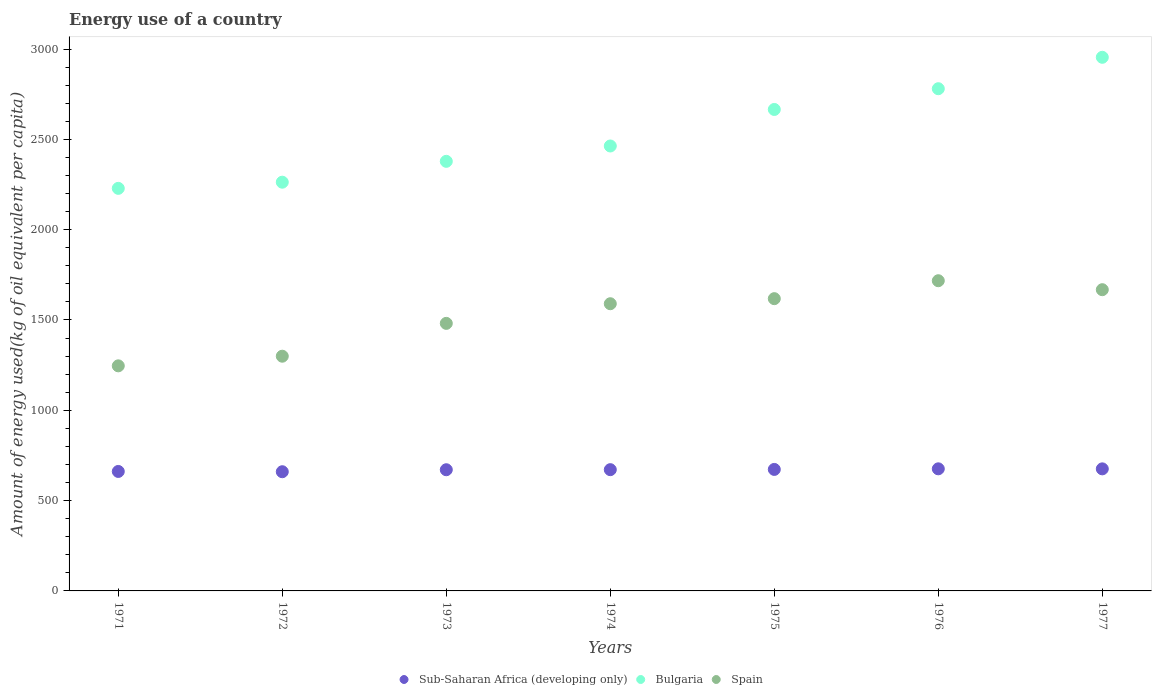Is the number of dotlines equal to the number of legend labels?
Your answer should be compact. Yes. What is the amount of energy used in in Sub-Saharan Africa (developing only) in 1973?
Your response must be concise. 670.89. Across all years, what is the maximum amount of energy used in in Sub-Saharan Africa (developing only)?
Provide a succinct answer. 675.94. Across all years, what is the minimum amount of energy used in in Bulgaria?
Offer a terse response. 2228.69. In which year was the amount of energy used in in Spain minimum?
Offer a very short reply. 1971. What is the total amount of energy used in in Bulgaria in the graph?
Offer a very short reply. 1.77e+04. What is the difference between the amount of energy used in in Bulgaria in 1971 and that in 1972?
Make the answer very short. -34.1. What is the difference between the amount of energy used in in Bulgaria in 1972 and the amount of energy used in in Spain in 1976?
Keep it short and to the point. 545.47. What is the average amount of energy used in in Sub-Saharan Africa (developing only) per year?
Offer a very short reply. 669.69. In the year 1975, what is the difference between the amount of energy used in in Spain and amount of energy used in in Sub-Saharan Africa (developing only)?
Offer a terse response. 945.38. What is the ratio of the amount of energy used in in Bulgaria in 1972 to that in 1974?
Give a very brief answer. 0.92. Is the amount of energy used in in Bulgaria in 1972 less than that in 1975?
Provide a short and direct response. Yes. Is the difference between the amount of energy used in in Spain in 1973 and 1977 greater than the difference between the amount of energy used in in Sub-Saharan Africa (developing only) in 1973 and 1977?
Make the answer very short. No. What is the difference between the highest and the second highest amount of energy used in in Sub-Saharan Africa (developing only)?
Your response must be concise. 0.17. What is the difference between the highest and the lowest amount of energy used in in Spain?
Ensure brevity in your answer.  471.22. Is the sum of the amount of energy used in in Bulgaria in 1973 and 1975 greater than the maximum amount of energy used in in Spain across all years?
Give a very brief answer. Yes. Is it the case that in every year, the sum of the amount of energy used in in Spain and amount of energy used in in Bulgaria  is greater than the amount of energy used in in Sub-Saharan Africa (developing only)?
Ensure brevity in your answer.  Yes. Does the amount of energy used in in Bulgaria monotonically increase over the years?
Your answer should be very brief. Yes. Is the amount of energy used in in Bulgaria strictly greater than the amount of energy used in in Spain over the years?
Your response must be concise. Yes. Is the amount of energy used in in Spain strictly less than the amount of energy used in in Bulgaria over the years?
Your response must be concise. Yes. How many dotlines are there?
Offer a very short reply. 3. Where does the legend appear in the graph?
Offer a very short reply. Bottom center. How many legend labels are there?
Give a very brief answer. 3. What is the title of the graph?
Your answer should be compact. Energy use of a country. Does "Gambia, The" appear as one of the legend labels in the graph?
Your answer should be very brief. No. What is the label or title of the Y-axis?
Ensure brevity in your answer.  Amount of energy used(kg of oil equivalent per capita). What is the Amount of energy used(kg of oil equivalent per capita) in Sub-Saharan Africa (developing only) in 1971?
Ensure brevity in your answer.  661.41. What is the Amount of energy used(kg of oil equivalent per capita) in Bulgaria in 1971?
Offer a very short reply. 2228.69. What is the Amount of energy used(kg of oil equivalent per capita) in Spain in 1971?
Provide a short and direct response. 1246.1. What is the Amount of energy used(kg of oil equivalent per capita) of Sub-Saharan Africa (developing only) in 1972?
Ensure brevity in your answer.  659.87. What is the Amount of energy used(kg of oil equivalent per capita) of Bulgaria in 1972?
Make the answer very short. 2262.79. What is the Amount of energy used(kg of oil equivalent per capita) in Spain in 1972?
Provide a short and direct response. 1299.43. What is the Amount of energy used(kg of oil equivalent per capita) of Sub-Saharan Africa (developing only) in 1973?
Your answer should be compact. 670.89. What is the Amount of energy used(kg of oil equivalent per capita) of Bulgaria in 1973?
Ensure brevity in your answer.  2378.25. What is the Amount of energy used(kg of oil equivalent per capita) of Spain in 1973?
Give a very brief answer. 1481.23. What is the Amount of energy used(kg of oil equivalent per capita) in Sub-Saharan Africa (developing only) in 1974?
Provide a succinct answer. 671.28. What is the Amount of energy used(kg of oil equivalent per capita) in Bulgaria in 1974?
Make the answer very short. 2463.24. What is the Amount of energy used(kg of oil equivalent per capita) in Spain in 1974?
Provide a short and direct response. 1589.97. What is the Amount of energy used(kg of oil equivalent per capita) in Sub-Saharan Africa (developing only) in 1975?
Ensure brevity in your answer.  672.65. What is the Amount of energy used(kg of oil equivalent per capita) of Bulgaria in 1975?
Ensure brevity in your answer.  2665.46. What is the Amount of energy used(kg of oil equivalent per capita) in Spain in 1975?
Provide a short and direct response. 1618.02. What is the Amount of energy used(kg of oil equivalent per capita) of Sub-Saharan Africa (developing only) in 1976?
Give a very brief answer. 675.94. What is the Amount of energy used(kg of oil equivalent per capita) of Bulgaria in 1976?
Offer a very short reply. 2780.33. What is the Amount of energy used(kg of oil equivalent per capita) of Spain in 1976?
Offer a very short reply. 1717.31. What is the Amount of energy used(kg of oil equivalent per capita) in Sub-Saharan Africa (developing only) in 1977?
Provide a succinct answer. 675.77. What is the Amount of energy used(kg of oil equivalent per capita) in Bulgaria in 1977?
Keep it short and to the point. 2954.27. What is the Amount of energy used(kg of oil equivalent per capita) of Spain in 1977?
Make the answer very short. 1667.65. Across all years, what is the maximum Amount of energy used(kg of oil equivalent per capita) of Sub-Saharan Africa (developing only)?
Offer a terse response. 675.94. Across all years, what is the maximum Amount of energy used(kg of oil equivalent per capita) in Bulgaria?
Your answer should be very brief. 2954.27. Across all years, what is the maximum Amount of energy used(kg of oil equivalent per capita) of Spain?
Offer a very short reply. 1717.31. Across all years, what is the minimum Amount of energy used(kg of oil equivalent per capita) in Sub-Saharan Africa (developing only)?
Your response must be concise. 659.87. Across all years, what is the minimum Amount of energy used(kg of oil equivalent per capita) in Bulgaria?
Keep it short and to the point. 2228.69. Across all years, what is the minimum Amount of energy used(kg of oil equivalent per capita) in Spain?
Give a very brief answer. 1246.1. What is the total Amount of energy used(kg of oil equivalent per capita) of Sub-Saharan Africa (developing only) in the graph?
Your answer should be very brief. 4687.81. What is the total Amount of energy used(kg of oil equivalent per capita) of Bulgaria in the graph?
Make the answer very short. 1.77e+04. What is the total Amount of energy used(kg of oil equivalent per capita) in Spain in the graph?
Offer a terse response. 1.06e+04. What is the difference between the Amount of energy used(kg of oil equivalent per capita) of Sub-Saharan Africa (developing only) in 1971 and that in 1972?
Make the answer very short. 1.54. What is the difference between the Amount of energy used(kg of oil equivalent per capita) of Bulgaria in 1971 and that in 1972?
Your answer should be compact. -34.1. What is the difference between the Amount of energy used(kg of oil equivalent per capita) of Spain in 1971 and that in 1972?
Your response must be concise. -53.33. What is the difference between the Amount of energy used(kg of oil equivalent per capita) of Sub-Saharan Africa (developing only) in 1971 and that in 1973?
Give a very brief answer. -9.49. What is the difference between the Amount of energy used(kg of oil equivalent per capita) in Bulgaria in 1971 and that in 1973?
Your answer should be compact. -149.57. What is the difference between the Amount of energy used(kg of oil equivalent per capita) in Spain in 1971 and that in 1973?
Offer a very short reply. -235.13. What is the difference between the Amount of energy used(kg of oil equivalent per capita) of Sub-Saharan Africa (developing only) in 1971 and that in 1974?
Offer a very short reply. -9.88. What is the difference between the Amount of energy used(kg of oil equivalent per capita) in Bulgaria in 1971 and that in 1974?
Your answer should be very brief. -234.56. What is the difference between the Amount of energy used(kg of oil equivalent per capita) of Spain in 1971 and that in 1974?
Your response must be concise. -343.87. What is the difference between the Amount of energy used(kg of oil equivalent per capita) of Sub-Saharan Africa (developing only) in 1971 and that in 1975?
Your answer should be compact. -11.24. What is the difference between the Amount of energy used(kg of oil equivalent per capita) in Bulgaria in 1971 and that in 1975?
Provide a succinct answer. -436.77. What is the difference between the Amount of energy used(kg of oil equivalent per capita) in Spain in 1971 and that in 1975?
Your answer should be compact. -371.92. What is the difference between the Amount of energy used(kg of oil equivalent per capita) in Sub-Saharan Africa (developing only) in 1971 and that in 1976?
Keep it short and to the point. -14.54. What is the difference between the Amount of energy used(kg of oil equivalent per capita) in Bulgaria in 1971 and that in 1976?
Provide a succinct answer. -551.64. What is the difference between the Amount of energy used(kg of oil equivalent per capita) of Spain in 1971 and that in 1976?
Provide a short and direct response. -471.22. What is the difference between the Amount of energy used(kg of oil equivalent per capita) of Sub-Saharan Africa (developing only) in 1971 and that in 1977?
Your response must be concise. -14.37. What is the difference between the Amount of energy used(kg of oil equivalent per capita) in Bulgaria in 1971 and that in 1977?
Provide a short and direct response. -725.58. What is the difference between the Amount of energy used(kg of oil equivalent per capita) in Spain in 1971 and that in 1977?
Provide a short and direct response. -421.55. What is the difference between the Amount of energy used(kg of oil equivalent per capita) in Sub-Saharan Africa (developing only) in 1972 and that in 1973?
Keep it short and to the point. -11.02. What is the difference between the Amount of energy used(kg of oil equivalent per capita) of Bulgaria in 1972 and that in 1973?
Offer a very short reply. -115.47. What is the difference between the Amount of energy used(kg of oil equivalent per capita) in Spain in 1972 and that in 1973?
Give a very brief answer. -181.8. What is the difference between the Amount of energy used(kg of oil equivalent per capita) of Sub-Saharan Africa (developing only) in 1972 and that in 1974?
Provide a short and direct response. -11.41. What is the difference between the Amount of energy used(kg of oil equivalent per capita) of Bulgaria in 1972 and that in 1974?
Your response must be concise. -200.46. What is the difference between the Amount of energy used(kg of oil equivalent per capita) in Spain in 1972 and that in 1974?
Your answer should be very brief. -290.54. What is the difference between the Amount of energy used(kg of oil equivalent per capita) in Sub-Saharan Africa (developing only) in 1972 and that in 1975?
Ensure brevity in your answer.  -12.78. What is the difference between the Amount of energy used(kg of oil equivalent per capita) in Bulgaria in 1972 and that in 1975?
Your answer should be compact. -402.67. What is the difference between the Amount of energy used(kg of oil equivalent per capita) in Spain in 1972 and that in 1975?
Offer a terse response. -318.59. What is the difference between the Amount of energy used(kg of oil equivalent per capita) of Sub-Saharan Africa (developing only) in 1972 and that in 1976?
Keep it short and to the point. -16.07. What is the difference between the Amount of energy used(kg of oil equivalent per capita) in Bulgaria in 1972 and that in 1976?
Offer a terse response. -517.55. What is the difference between the Amount of energy used(kg of oil equivalent per capita) in Spain in 1972 and that in 1976?
Keep it short and to the point. -417.88. What is the difference between the Amount of energy used(kg of oil equivalent per capita) of Sub-Saharan Africa (developing only) in 1972 and that in 1977?
Your answer should be very brief. -15.9. What is the difference between the Amount of energy used(kg of oil equivalent per capita) in Bulgaria in 1972 and that in 1977?
Keep it short and to the point. -691.48. What is the difference between the Amount of energy used(kg of oil equivalent per capita) of Spain in 1972 and that in 1977?
Keep it short and to the point. -368.21. What is the difference between the Amount of energy used(kg of oil equivalent per capita) of Sub-Saharan Africa (developing only) in 1973 and that in 1974?
Keep it short and to the point. -0.39. What is the difference between the Amount of energy used(kg of oil equivalent per capita) of Bulgaria in 1973 and that in 1974?
Make the answer very short. -84.99. What is the difference between the Amount of energy used(kg of oil equivalent per capita) in Spain in 1973 and that in 1974?
Your response must be concise. -108.74. What is the difference between the Amount of energy used(kg of oil equivalent per capita) in Sub-Saharan Africa (developing only) in 1973 and that in 1975?
Offer a terse response. -1.75. What is the difference between the Amount of energy used(kg of oil equivalent per capita) of Bulgaria in 1973 and that in 1975?
Give a very brief answer. -287.21. What is the difference between the Amount of energy used(kg of oil equivalent per capita) of Spain in 1973 and that in 1975?
Keep it short and to the point. -136.79. What is the difference between the Amount of energy used(kg of oil equivalent per capita) in Sub-Saharan Africa (developing only) in 1973 and that in 1976?
Your answer should be very brief. -5.05. What is the difference between the Amount of energy used(kg of oil equivalent per capita) of Bulgaria in 1973 and that in 1976?
Make the answer very short. -402.08. What is the difference between the Amount of energy used(kg of oil equivalent per capita) of Spain in 1973 and that in 1976?
Keep it short and to the point. -236.08. What is the difference between the Amount of energy used(kg of oil equivalent per capita) of Sub-Saharan Africa (developing only) in 1973 and that in 1977?
Make the answer very short. -4.88. What is the difference between the Amount of energy used(kg of oil equivalent per capita) of Bulgaria in 1973 and that in 1977?
Offer a terse response. -576.01. What is the difference between the Amount of energy used(kg of oil equivalent per capita) in Spain in 1973 and that in 1977?
Provide a succinct answer. -186.42. What is the difference between the Amount of energy used(kg of oil equivalent per capita) in Sub-Saharan Africa (developing only) in 1974 and that in 1975?
Offer a very short reply. -1.36. What is the difference between the Amount of energy used(kg of oil equivalent per capita) in Bulgaria in 1974 and that in 1975?
Ensure brevity in your answer.  -202.22. What is the difference between the Amount of energy used(kg of oil equivalent per capita) in Spain in 1974 and that in 1975?
Ensure brevity in your answer.  -28.05. What is the difference between the Amount of energy used(kg of oil equivalent per capita) in Sub-Saharan Africa (developing only) in 1974 and that in 1976?
Your answer should be compact. -4.66. What is the difference between the Amount of energy used(kg of oil equivalent per capita) of Bulgaria in 1974 and that in 1976?
Ensure brevity in your answer.  -317.09. What is the difference between the Amount of energy used(kg of oil equivalent per capita) in Spain in 1974 and that in 1976?
Give a very brief answer. -127.34. What is the difference between the Amount of energy used(kg of oil equivalent per capita) of Sub-Saharan Africa (developing only) in 1974 and that in 1977?
Your answer should be very brief. -4.49. What is the difference between the Amount of energy used(kg of oil equivalent per capita) of Bulgaria in 1974 and that in 1977?
Your answer should be very brief. -491.02. What is the difference between the Amount of energy used(kg of oil equivalent per capita) of Spain in 1974 and that in 1977?
Make the answer very short. -77.68. What is the difference between the Amount of energy used(kg of oil equivalent per capita) of Sub-Saharan Africa (developing only) in 1975 and that in 1976?
Your answer should be compact. -3.3. What is the difference between the Amount of energy used(kg of oil equivalent per capita) in Bulgaria in 1975 and that in 1976?
Your answer should be very brief. -114.87. What is the difference between the Amount of energy used(kg of oil equivalent per capita) in Spain in 1975 and that in 1976?
Provide a succinct answer. -99.29. What is the difference between the Amount of energy used(kg of oil equivalent per capita) in Sub-Saharan Africa (developing only) in 1975 and that in 1977?
Make the answer very short. -3.13. What is the difference between the Amount of energy used(kg of oil equivalent per capita) in Bulgaria in 1975 and that in 1977?
Provide a short and direct response. -288.81. What is the difference between the Amount of energy used(kg of oil equivalent per capita) of Spain in 1975 and that in 1977?
Ensure brevity in your answer.  -49.63. What is the difference between the Amount of energy used(kg of oil equivalent per capita) of Sub-Saharan Africa (developing only) in 1976 and that in 1977?
Your response must be concise. 0.17. What is the difference between the Amount of energy used(kg of oil equivalent per capita) of Bulgaria in 1976 and that in 1977?
Offer a terse response. -173.94. What is the difference between the Amount of energy used(kg of oil equivalent per capita) of Spain in 1976 and that in 1977?
Provide a short and direct response. 49.67. What is the difference between the Amount of energy used(kg of oil equivalent per capita) of Sub-Saharan Africa (developing only) in 1971 and the Amount of energy used(kg of oil equivalent per capita) of Bulgaria in 1972?
Ensure brevity in your answer.  -1601.38. What is the difference between the Amount of energy used(kg of oil equivalent per capita) of Sub-Saharan Africa (developing only) in 1971 and the Amount of energy used(kg of oil equivalent per capita) of Spain in 1972?
Your answer should be compact. -638.03. What is the difference between the Amount of energy used(kg of oil equivalent per capita) in Bulgaria in 1971 and the Amount of energy used(kg of oil equivalent per capita) in Spain in 1972?
Your answer should be compact. 929.26. What is the difference between the Amount of energy used(kg of oil equivalent per capita) of Sub-Saharan Africa (developing only) in 1971 and the Amount of energy used(kg of oil equivalent per capita) of Bulgaria in 1973?
Provide a short and direct response. -1716.85. What is the difference between the Amount of energy used(kg of oil equivalent per capita) in Sub-Saharan Africa (developing only) in 1971 and the Amount of energy used(kg of oil equivalent per capita) in Spain in 1973?
Provide a succinct answer. -819.82. What is the difference between the Amount of energy used(kg of oil equivalent per capita) in Bulgaria in 1971 and the Amount of energy used(kg of oil equivalent per capita) in Spain in 1973?
Provide a succinct answer. 747.46. What is the difference between the Amount of energy used(kg of oil equivalent per capita) in Sub-Saharan Africa (developing only) in 1971 and the Amount of energy used(kg of oil equivalent per capita) in Bulgaria in 1974?
Your answer should be compact. -1801.84. What is the difference between the Amount of energy used(kg of oil equivalent per capita) of Sub-Saharan Africa (developing only) in 1971 and the Amount of energy used(kg of oil equivalent per capita) of Spain in 1974?
Keep it short and to the point. -928.56. What is the difference between the Amount of energy used(kg of oil equivalent per capita) in Bulgaria in 1971 and the Amount of energy used(kg of oil equivalent per capita) in Spain in 1974?
Make the answer very short. 638.72. What is the difference between the Amount of energy used(kg of oil equivalent per capita) in Sub-Saharan Africa (developing only) in 1971 and the Amount of energy used(kg of oil equivalent per capita) in Bulgaria in 1975?
Make the answer very short. -2004.05. What is the difference between the Amount of energy used(kg of oil equivalent per capita) of Sub-Saharan Africa (developing only) in 1971 and the Amount of energy used(kg of oil equivalent per capita) of Spain in 1975?
Keep it short and to the point. -956.62. What is the difference between the Amount of energy used(kg of oil equivalent per capita) of Bulgaria in 1971 and the Amount of energy used(kg of oil equivalent per capita) of Spain in 1975?
Your answer should be compact. 610.67. What is the difference between the Amount of energy used(kg of oil equivalent per capita) in Sub-Saharan Africa (developing only) in 1971 and the Amount of energy used(kg of oil equivalent per capita) in Bulgaria in 1976?
Offer a very short reply. -2118.93. What is the difference between the Amount of energy used(kg of oil equivalent per capita) in Sub-Saharan Africa (developing only) in 1971 and the Amount of energy used(kg of oil equivalent per capita) in Spain in 1976?
Provide a succinct answer. -1055.91. What is the difference between the Amount of energy used(kg of oil equivalent per capita) of Bulgaria in 1971 and the Amount of energy used(kg of oil equivalent per capita) of Spain in 1976?
Keep it short and to the point. 511.37. What is the difference between the Amount of energy used(kg of oil equivalent per capita) of Sub-Saharan Africa (developing only) in 1971 and the Amount of energy used(kg of oil equivalent per capita) of Bulgaria in 1977?
Offer a terse response. -2292.86. What is the difference between the Amount of energy used(kg of oil equivalent per capita) in Sub-Saharan Africa (developing only) in 1971 and the Amount of energy used(kg of oil equivalent per capita) in Spain in 1977?
Offer a terse response. -1006.24. What is the difference between the Amount of energy used(kg of oil equivalent per capita) in Bulgaria in 1971 and the Amount of energy used(kg of oil equivalent per capita) in Spain in 1977?
Offer a very short reply. 561.04. What is the difference between the Amount of energy used(kg of oil equivalent per capita) in Sub-Saharan Africa (developing only) in 1972 and the Amount of energy used(kg of oil equivalent per capita) in Bulgaria in 1973?
Offer a very short reply. -1718.38. What is the difference between the Amount of energy used(kg of oil equivalent per capita) in Sub-Saharan Africa (developing only) in 1972 and the Amount of energy used(kg of oil equivalent per capita) in Spain in 1973?
Offer a terse response. -821.36. What is the difference between the Amount of energy used(kg of oil equivalent per capita) in Bulgaria in 1972 and the Amount of energy used(kg of oil equivalent per capita) in Spain in 1973?
Make the answer very short. 781.56. What is the difference between the Amount of energy used(kg of oil equivalent per capita) in Sub-Saharan Africa (developing only) in 1972 and the Amount of energy used(kg of oil equivalent per capita) in Bulgaria in 1974?
Your answer should be very brief. -1803.37. What is the difference between the Amount of energy used(kg of oil equivalent per capita) of Sub-Saharan Africa (developing only) in 1972 and the Amount of energy used(kg of oil equivalent per capita) of Spain in 1974?
Provide a short and direct response. -930.1. What is the difference between the Amount of energy used(kg of oil equivalent per capita) of Bulgaria in 1972 and the Amount of energy used(kg of oil equivalent per capita) of Spain in 1974?
Make the answer very short. 672.82. What is the difference between the Amount of energy used(kg of oil equivalent per capita) of Sub-Saharan Africa (developing only) in 1972 and the Amount of energy used(kg of oil equivalent per capita) of Bulgaria in 1975?
Provide a short and direct response. -2005.59. What is the difference between the Amount of energy used(kg of oil equivalent per capita) in Sub-Saharan Africa (developing only) in 1972 and the Amount of energy used(kg of oil equivalent per capita) in Spain in 1975?
Your answer should be very brief. -958.15. What is the difference between the Amount of energy used(kg of oil equivalent per capita) in Bulgaria in 1972 and the Amount of energy used(kg of oil equivalent per capita) in Spain in 1975?
Offer a terse response. 644.77. What is the difference between the Amount of energy used(kg of oil equivalent per capita) in Sub-Saharan Africa (developing only) in 1972 and the Amount of energy used(kg of oil equivalent per capita) in Bulgaria in 1976?
Your answer should be compact. -2120.46. What is the difference between the Amount of energy used(kg of oil equivalent per capita) in Sub-Saharan Africa (developing only) in 1972 and the Amount of energy used(kg of oil equivalent per capita) in Spain in 1976?
Provide a succinct answer. -1057.44. What is the difference between the Amount of energy used(kg of oil equivalent per capita) in Bulgaria in 1972 and the Amount of energy used(kg of oil equivalent per capita) in Spain in 1976?
Offer a terse response. 545.47. What is the difference between the Amount of energy used(kg of oil equivalent per capita) in Sub-Saharan Africa (developing only) in 1972 and the Amount of energy used(kg of oil equivalent per capita) in Bulgaria in 1977?
Provide a succinct answer. -2294.4. What is the difference between the Amount of energy used(kg of oil equivalent per capita) in Sub-Saharan Africa (developing only) in 1972 and the Amount of energy used(kg of oil equivalent per capita) in Spain in 1977?
Make the answer very short. -1007.78. What is the difference between the Amount of energy used(kg of oil equivalent per capita) of Bulgaria in 1972 and the Amount of energy used(kg of oil equivalent per capita) of Spain in 1977?
Offer a very short reply. 595.14. What is the difference between the Amount of energy used(kg of oil equivalent per capita) in Sub-Saharan Africa (developing only) in 1973 and the Amount of energy used(kg of oil equivalent per capita) in Bulgaria in 1974?
Give a very brief answer. -1792.35. What is the difference between the Amount of energy used(kg of oil equivalent per capita) of Sub-Saharan Africa (developing only) in 1973 and the Amount of energy used(kg of oil equivalent per capita) of Spain in 1974?
Ensure brevity in your answer.  -919.08. What is the difference between the Amount of energy used(kg of oil equivalent per capita) of Bulgaria in 1973 and the Amount of energy used(kg of oil equivalent per capita) of Spain in 1974?
Give a very brief answer. 788.28. What is the difference between the Amount of energy used(kg of oil equivalent per capita) of Sub-Saharan Africa (developing only) in 1973 and the Amount of energy used(kg of oil equivalent per capita) of Bulgaria in 1975?
Offer a very short reply. -1994.57. What is the difference between the Amount of energy used(kg of oil equivalent per capita) in Sub-Saharan Africa (developing only) in 1973 and the Amount of energy used(kg of oil equivalent per capita) in Spain in 1975?
Offer a terse response. -947.13. What is the difference between the Amount of energy used(kg of oil equivalent per capita) of Bulgaria in 1973 and the Amount of energy used(kg of oil equivalent per capita) of Spain in 1975?
Make the answer very short. 760.23. What is the difference between the Amount of energy used(kg of oil equivalent per capita) of Sub-Saharan Africa (developing only) in 1973 and the Amount of energy used(kg of oil equivalent per capita) of Bulgaria in 1976?
Provide a short and direct response. -2109.44. What is the difference between the Amount of energy used(kg of oil equivalent per capita) in Sub-Saharan Africa (developing only) in 1973 and the Amount of energy used(kg of oil equivalent per capita) in Spain in 1976?
Provide a succinct answer. -1046.42. What is the difference between the Amount of energy used(kg of oil equivalent per capita) in Bulgaria in 1973 and the Amount of energy used(kg of oil equivalent per capita) in Spain in 1976?
Give a very brief answer. 660.94. What is the difference between the Amount of energy used(kg of oil equivalent per capita) in Sub-Saharan Africa (developing only) in 1973 and the Amount of energy used(kg of oil equivalent per capita) in Bulgaria in 1977?
Offer a terse response. -2283.37. What is the difference between the Amount of energy used(kg of oil equivalent per capita) of Sub-Saharan Africa (developing only) in 1973 and the Amount of energy used(kg of oil equivalent per capita) of Spain in 1977?
Make the answer very short. -996.75. What is the difference between the Amount of energy used(kg of oil equivalent per capita) in Bulgaria in 1973 and the Amount of energy used(kg of oil equivalent per capita) in Spain in 1977?
Your answer should be compact. 710.61. What is the difference between the Amount of energy used(kg of oil equivalent per capita) of Sub-Saharan Africa (developing only) in 1974 and the Amount of energy used(kg of oil equivalent per capita) of Bulgaria in 1975?
Offer a terse response. -1994.18. What is the difference between the Amount of energy used(kg of oil equivalent per capita) of Sub-Saharan Africa (developing only) in 1974 and the Amount of energy used(kg of oil equivalent per capita) of Spain in 1975?
Keep it short and to the point. -946.74. What is the difference between the Amount of energy used(kg of oil equivalent per capita) in Bulgaria in 1974 and the Amount of energy used(kg of oil equivalent per capita) in Spain in 1975?
Provide a succinct answer. 845.22. What is the difference between the Amount of energy used(kg of oil equivalent per capita) in Sub-Saharan Africa (developing only) in 1974 and the Amount of energy used(kg of oil equivalent per capita) in Bulgaria in 1976?
Offer a terse response. -2109.05. What is the difference between the Amount of energy used(kg of oil equivalent per capita) of Sub-Saharan Africa (developing only) in 1974 and the Amount of energy used(kg of oil equivalent per capita) of Spain in 1976?
Provide a short and direct response. -1046.03. What is the difference between the Amount of energy used(kg of oil equivalent per capita) in Bulgaria in 1974 and the Amount of energy used(kg of oil equivalent per capita) in Spain in 1976?
Provide a succinct answer. 745.93. What is the difference between the Amount of energy used(kg of oil equivalent per capita) of Sub-Saharan Africa (developing only) in 1974 and the Amount of energy used(kg of oil equivalent per capita) of Bulgaria in 1977?
Give a very brief answer. -2282.98. What is the difference between the Amount of energy used(kg of oil equivalent per capita) in Sub-Saharan Africa (developing only) in 1974 and the Amount of energy used(kg of oil equivalent per capita) in Spain in 1977?
Offer a terse response. -996.36. What is the difference between the Amount of energy used(kg of oil equivalent per capita) in Bulgaria in 1974 and the Amount of energy used(kg of oil equivalent per capita) in Spain in 1977?
Ensure brevity in your answer.  795.6. What is the difference between the Amount of energy used(kg of oil equivalent per capita) in Sub-Saharan Africa (developing only) in 1975 and the Amount of energy used(kg of oil equivalent per capita) in Bulgaria in 1976?
Ensure brevity in your answer.  -2107.69. What is the difference between the Amount of energy used(kg of oil equivalent per capita) of Sub-Saharan Africa (developing only) in 1975 and the Amount of energy used(kg of oil equivalent per capita) of Spain in 1976?
Offer a very short reply. -1044.67. What is the difference between the Amount of energy used(kg of oil equivalent per capita) of Bulgaria in 1975 and the Amount of energy used(kg of oil equivalent per capita) of Spain in 1976?
Offer a terse response. 948.15. What is the difference between the Amount of energy used(kg of oil equivalent per capita) in Sub-Saharan Africa (developing only) in 1975 and the Amount of energy used(kg of oil equivalent per capita) in Bulgaria in 1977?
Ensure brevity in your answer.  -2281.62. What is the difference between the Amount of energy used(kg of oil equivalent per capita) of Sub-Saharan Africa (developing only) in 1975 and the Amount of energy used(kg of oil equivalent per capita) of Spain in 1977?
Your answer should be very brief. -995. What is the difference between the Amount of energy used(kg of oil equivalent per capita) of Bulgaria in 1975 and the Amount of energy used(kg of oil equivalent per capita) of Spain in 1977?
Your response must be concise. 997.81. What is the difference between the Amount of energy used(kg of oil equivalent per capita) in Sub-Saharan Africa (developing only) in 1976 and the Amount of energy used(kg of oil equivalent per capita) in Bulgaria in 1977?
Provide a succinct answer. -2278.32. What is the difference between the Amount of energy used(kg of oil equivalent per capita) of Sub-Saharan Africa (developing only) in 1976 and the Amount of energy used(kg of oil equivalent per capita) of Spain in 1977?
Your answer should be compact. -991.7. What is the difference between the Amount of energy used(kg of oil equivalent per capita) of Bulgaria in 1976 and the Amount of energy used(kg of oil equivalent per capita) of Spain in 1977?
Keep it short and to the point. 1112.69. What is the average Amount of energy used(kg of oil equivalent per capita) in Sub-Saharan Africa (developing only) per year?
Make the answer very short. 669.69. What is the average Amount of energy used(kg of oil equivalent per capita) in Bulgaria per year?
Ensure brevity in your answer.  2533.29. What is the average Amount of energy used(kg of oil equivalent per capita) of Spain per year?
Offer a very short reply. 1517.1. In the year 1971, what is the difference between the Amount of energy used(kg of oil equivalent per capita) of Sub-Saharan Africa (developing only) and Amount of energy used(kg of oil equivalent per capita) of Bulgaria?
Provide a succinct answer. -1567.28. In the year 1971, what is the difference between the Amount of energy used(kg of oil equivalent per capita) in Sub-Saharan Africa (developing only) and Amount of energy used(kg of oil equivalent per capita) in Spain?
Provide a short and direct response. -584.69. In the year 1971, what is the difference between the Amount of energy used(kg of oil equivalent per capita) in Bulgaria and Amount of energy used(kg of oil equivalent per capita) in Spain?
Provide a short and direct response. 982.59. In the year 1972, what is the difference between the Amount of energy used(kg of oil equivalent per capita) of Sub-Saharan Africa (developing only) and Amount of energy used(kg of oil equivalent per capita) of Bulgaria?
Ensure brevity in your answer.  -1602.92. In the year 1972, what is the difference between the Amount of energy used(kg of oil equivalent per capita) of Sub-Saharan Africa (developing only) and Amount of energy used(kg of oil equivalent per capita) of Spain?
Provide a succinct answer. -639.56. In the year 1972, what is the difference between the Amount of energy used(kg of oil equivalent per capita) of Bulgaria and Amount of energy used(kg of oil equivalent per capita) of Spain?
Keep it short and to the point. 963.36. In the year 1973, what is the difference between the Amount of energy used(kg of oil equivalent per capita) in Sub-Saharan Africa (developing only) and Amount of energy used(kg of oil equivalent per capita) in Bulgaria?
Make the answer very short. -1707.36. In the year 1973, what is the difference between the Amount of energy used(kg of oil equivalent per capita) of Sub-Saharan Africa (developing only) and Amount of energy used(kg of oil equivalent per capita) of Spain?
Offer a terse response. -810.34. In the year 1973, what is the difference between the Amount of energy used(kg of oil equivalent per capita) of Bulgaria and Amount of energy used(kg of oil equivalent per capita) of Spain?
Offer a very short reply. 897.03. In the year 1974, what is the difference between the Amount of energy used(kg of oil equivalent per capita) in Sub-Saharan Africa (developing only) and Amount of energy used(kg of oil equivalent per capita) in Bulgaria?
Ensure brevity in your answer.  -1791.96. In the year 1974, what is the difference between the Amount of energy used(kg of oil equivalent per capita) in Sub-Saharan Africa (developing only) and Amount of energy used(kg of oil equivalent per capita) in Spain?
Offer a terse response. -918.69. In the year 1974, what is the difference between the Amount of energy used(kg of oil equivalent per capita) of Bulgaria and Amount of energy used(kg of oil equivalent per capita) of Spain?
Provide a short and direct response. 873.27. In the year 1975, what is the difference between the Amount of energy used(kg of oil equivalent per capita) of Sub-Saharan Africa (developing only) and Amount of energy used(kg of oil equivalent per capita) of Bulgaria?
Provide a succinct answer. -1992.81. In the year 1975, what is the difference between the Amount of energy used(kg of oil equivalent per capita) of Sub-Saharan Africa (developing only) and Amount of energy used(kg of oil equivalent per capita) of Spain?
Your response must be concise. -945.38. In the year 1975, what is the difference between the Amount of energy used(kg of oil equivalent per capita) of Bulgaria and Amount of energy used(kg of oil equivalent per capita) of Spain?
Ensure brevity in your answer.  1047.44. In the year 1976, what is the difference between the Amount of energy used(kg of oil equivalent per capita) in Sub-Saharan Africa (developing only) and Amount of energy used(kg of oil equivalent per capita) in Bulgaria?
Provide a succinct answer. -2104.39. In the year 1976, what is the difference between the Amount of energy used(kg of oil equivalent per capita) of Sub-Saharan Africa (developing only) and Amount of energy used(kg of oil equivalent per capita) of Spain?
Provide a succinct answer. -1041.37. In the year 1976, what is the difference between the Amount of energy used(kg of oil equivalent per capita) of Bulgaria and Amount of energy used(kg of oil equivalent per capita) of Spain?
Your answer should be very brief. 1063.02. In the year 1977, what is the difference between the Amount of energy used(kg of oil equivalent per capita) in Sub-Saharan Africa (developing only) and Amount of energy used(kg of oil equivalent per capita) in Bulgaria?
Ensure brevity in your answer.  -2278.49. In the year 1977, what is the difference between the Amount of energy used(kg of oil equivalent per capita) in Sub-Saharan Africa (developing only) and Amount of energy used(kg of oil equivalent per capita) in Spain?
Provide a short and direct response. -991.87. In the year 1977, what is the difference between the Amount of energy used(kg of oil equivalent per capita) in Bulgaria and Amount of energy used(kg of oil equivalent per capita) in Spain?
Give a very brief answer. 1286.62. What is the ratio of the Amount of energy used(kg of oil equivalent per capita) in Bulgaria in 1971 to that in 1972?
Give a very brief answer. 0.98. What is the ratio of the Amount of energy used(kg of oil equivalent per capita) of Spain in 1971 to that in 1972?
Offer a very short reply. 0.96. What is the ratio of the Amount of energy used(kg of oil equivalent per capita) of Sub-Saharan Africa (developing only) in 1971 to that in 1973?
Make the answer very short. 0.99. What is the ratio of the Amount of energy used(kg of oil equivalent per capita) in Bulgaria in 1971 to that in 1973?
Offer a terse response. 0.94. What is the ratio of the Amount of energy used(kg of oil equivalent per capita) in Spain in 1971 to that in 1973?
Your answer should be compact. 0.84. What is the ratio of the Amount of energy used(kg of oil equivalent per capita) in Sub-Saharan Africa (developing only) in 1971 to that in 1974?
Your response must be concise. 0.99. What is the ratio of the Amount of energy used(kg of oil equivalent per capita) of Bulgaria in 1971 to that in 1974?
Ensure brevity in your answer.  0.9. What is the ratio of the Amount of energy used(kg of oil equivalent per capita) of Spain in 1971 to that in 1974?
Give a very brief answer. 0.78. What is the ratio of the Amount of energy used(kg of oil equivalent per capita) of Sub-Saharan Africa (developing only) in 1971 to that in 1975?
Your response must be concise. 0.98. What is the ratio of the Amount of energy used(kg of oil equivalent per capita) in Bulgaria in 1971 to that in 1975?
Your answer should be compact. 0.84. What is the ratio of the Amount of energy used(kg of oil equivalent per capita) of Spain in 1971 to that in 1975?
Offer a terse response. 0.77. What is the ratio of the Amount of energy used(kg of oil equivalent per capita) of Sub-Saharan Africa (developing only) in 1971 to that in 1976?
Ensure brevity in your answer.  0.98. What is the ratio of the Amount of energy used(kg of oil equivalent per capita) of Bulgaria in 1971 to that in 1976?
Your response must be concise. 0.8. What is the ratio of the Amount of energy used(kg of oil equivalent per capita) in Spain in 1971 to that in 1976?
Provide a short and direct response. 0.73. What is the ratio of the Amount of energy used(kg of oil equivalent per capita) in Sub-Saharan Africa (developing only) in 1971 to that in 1977?
Give a very brief answer. 0.98. What is the ratio of the Amount of energy used(kg of oil equivalent per capita) of Bulgaria in 1971 to that in 1977?
Provide a succinct answer. 0.75. What is the ratio of the Amount of energy used(kg of oil equivalent per capita) in Spain in 1971 to that in 1977?
Offer a very short reply. 0.75. What is the ratio of the Amount of energy used(kg of oil equivalent per capita) in Sub-Saharan Africa (developing only) in 1972 to that in 1973?
Your response must be concise. 0.98. What is the ratio of the Amount of energy used(kg of oil equivalent per capita) in Bulgaria in 1972 to that in 1973?
Your answer should be compact. 0.95. What is the ratio of the Amount of energy used(kg of oil equivalent per capita) in Spain in 1972 to that in 1973?
Your answer should be compact. 0.88. What is the ratio of the Amount of energy used(kg of oil equivalent per capita) in Bulgaria in 1972 to that in 1974?
Your answer should be compact. 0.92. What is the ratio of the Amount of energy used(kg of oil equivalent per capita) of Spain in 1972 to that in 1974?
Your answer should be very brief. 0.82. What is the ratio of the Amount of energy used(kg of oil equivalent per capita) in Bulgaria in 1972 to that in 1975?
Make the answer very short. 0.85. What is the ratio of the Amount of energy used(kg of oil equivalent per capita) in Spain in 1972 to that in 1975?
Ensure brevity in your answer.  0.8. What is the ratio of the Amount of energy used(kg of oil equivalent per capita) of Sub-Saharan Africa (developing only) in 1972 to that in 1976?
Offer a terse response. 0.98. What is the ratio of the Amount of energy used(kg of oil equivalent per capita) of Bulgaria in 1972 to that in 1976?
Your answer should be compact. 0.81. What is the ratio of the Amount of energy used(kg of oil equivalent per capita) in Spain in 1972 to that in 1976?
Provide a succinct answer. 0.76. What is the ratio of the Amount of energy used(kg of oil equivalent per capita) of Sub-Saharan Africa (developing only) in 1972 to that in 1977?
Provide a short and direct response. 0.98. What is the ratio of the Amount of energy used(kg of oil equivalent per capita) in Bulgaria in 1972 to that in 1977?
Make the answer very short. 0.77. What is the ratio of the Amount of energy used(kg of oil equivalent per capita) of Spain in 1972 to that in 1977?
Make the answer very short. 0.78. What is the ratio of the Amount of energy used(kg of oil equivalent per capita) of Sub-Saharan Africa (developing only) in 1973 to that in 1974?
Your answer should be compact. 1. What is the ratio of the Amount of energy used(kg of oil equivalent per capita) of Bulgaria in 1973 to that in 1974?
Provide a succinct answer. 0.97. What is the ratio of the Amount of energy used(kg of oil equivalent per capita) in Spain in 1973 to that in 1974?
Keep it short and to the point. 0.93. What is the ratio of the Amount of energy used(kg of oil equivalent per capita) of Bulgaria in 1973 to that in 1975?
Make the answer very short. 0.89. What is the ratio of the Amount of energy used(kg of oil equivalent per capita) in Spain in 1973 to that in 1975?
Offer a terse response. 0.92. What is the ratio of the Amount of energy used(kg of oil equivalent per capita) in Bulgaria in 1973 to that in 1976?
Provide a short and direct response. 0.86. What is the ratio of the Amount of energy used(kg of oil equivalent per capita) of Spain in 1973 to that in 1976?
Provide a short and direct response. 0.86. What is the ratio of the Amount of energy used(kg of oil equivalent per capita) in Bulgaria in 1973 to that in 1977?
Make the answer very short. 0.81. What is the ratio of the Amount of energy used(kg of oil equivalent per capita) of Spain in 1973 to that in 1977?
Offer a terse response. 0.89. What is the ratio of the Amount of energy used(kg of oil equivalent per capita) of Bulgaria in 1974 to that in 1975?
Your response must be concise. 0.92. What is the ratio of the Amount of energy used(kg of oil equivalent per capita) in Spain in 1974 to that in 1975?
Your answer should be very brief. 0.98. What is the ratio of the Amount of energy used(kg of oil equivalent per capita) in Bulgaria in 1974 to that in 1976?
Offer a terse response. 0.89. What is the ratio of the Amount of energy used(kg of oil equivalent per capita) in Spain in 1974 to that in 1976?
Provide a succinct answer. 0.93. What is the ratio of the Amount of energy used(kg of oil equivalent per capita) of Sub-Saharan Africa (developing only) in 1974 to that in 1977?
Your response must be concise. 0.99. What is the ratio of the Amount of energy used(kg of oil equivalent per capita) in Bulgaria in 1974 to that in 1977?
Provide a succinct answer. 0.83. What is the ratio of the Amount of energy used(kg of oil equivalent per capita) in Spain in 1974 to that in 1977?
Offer a terse response. 0.95. What is the ratio of the Amount of energy used(kg of oil equivalent per capita) in Sub-Saharan Africa (developing only) in 1975 to that in 1976?
Make the answer very short. 1. What is the ratio of the Amount of energy used(kg of oil equivalent per capita) of Bulgaria in 1975 to that in 1976?
Your response must be concise. 0.96. What is the ratio of the Amount of energy used(kg of oil equivalent per capita) in Spain in 1975 to that in 1976?
Give a very brief answer. 0.94. What is the ratio of the Amount of energy used(kg of oil equivalent per capita) in Sub-Saharan Africa (developing only) in 1975 to that in 1977?
Keep it short and to the point. 1. What is the ratio of the Amount of energy used(kg of oil equivalent per capita) in Bulgaria in 1975 to that in 1977?
Provide a short and direct response. 0.9. What is the ratio of the Amount of energy used(kg of oil equivalent per capita) in Spain in 1975 to that in 1977?
Your answer should be compact. 0.97. What is the ratio of the Amount of energy used(kg of oil equivalent per capita) of Sub-Saharan Africa (developing only) in 1976 to that in 1977?
Offer a very short reply. 1. What is the ratio of the Amount of energy used(kg of oil equivalent per capita) in Bulgaria in 1976 to that in 1977?
Your answer should be very brief. 0.94. What is the ratio of the Amount of energy used(kg of oil equivalent per capita) of Spain in 1976 to that in 1977?
Provide a short and direct response. 1.03. What is the difference between the highest and the second highest Amount of energy used(kg of oil equivalent per capita) in Sub-Saharan Africa (developing only)?
Provide a short and direct response. 0.17. What is the difference between the highest and the second highest Amount of energy used(kg of oil equivalent per capita) of Bulgaria?
Ensure brevity in your answer.  173.94. What is the difference between the highest and the second highest Amount of energy used(kg of oil equivalent per capita) of Spain?
Ensure brevity in your answer.  49.67. What is the difference between the highest and the lowest Amount of energy used(kg of oil equivalent per capita) in Sub-Saharan Africa (developing only)?
Offer a very short reply. 16.07. What is the difference between the highest and the lowest Amount of energy used(kg of oil equivalent per capita) of Bulgaria?
Give a very brief answer. 725.58. What is the difference between the highest and the lowest Amount of energy used(kg of oil equivalent per capita) of Spain?
Provide a succinct answer. 471.22. 